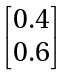<formula> <loc_0><loc_0><loc_500><loc_500>\begin{bmatrix} 0 . 4 \\ 0 . 6 \\ \end{bmatrix}</formula> 